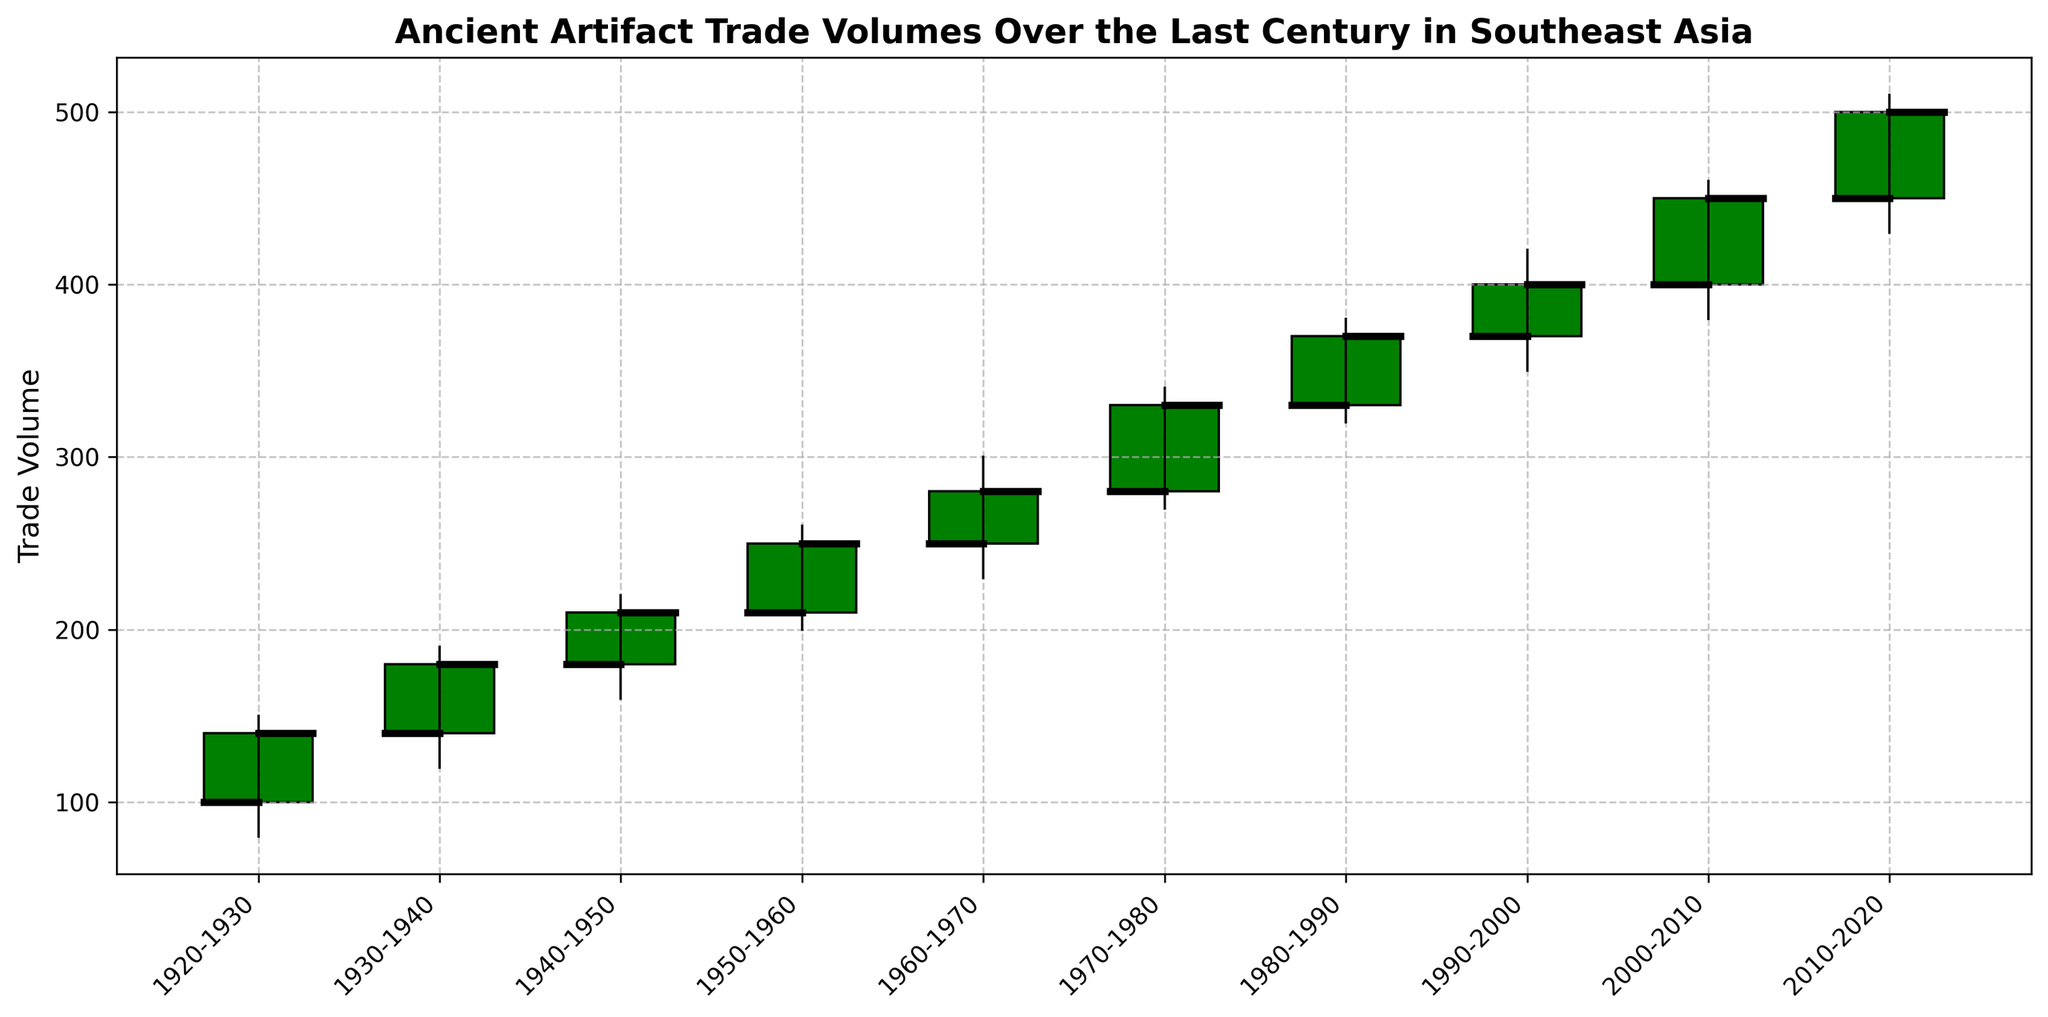What period shows the highest trade volume? The highest trade volume corresponds to the highest value in the "Close" column, which is 500 in the period 2010-2020.
Answer: 2010-2020 During which period does the trade volume see the most significant increase compared to the previous period? To determine this, we need to calculate the difference between consecutive "Close" values and identify the largest increase. From 1920-1930 to 1930-1940, the increase is 40 (180-140); from 1930-1940 to 1940-1950, it is 30 (210-180); and so on. The most significant increase is from 2000-2010 to 2010-2020, which is 50 (500-450).
Answer: 2000-2010 to 2010-2020 What is the smallest trade volume recorded in the figure, and during which period is it observed? The smallest trade volume corresponds to the lowest value in the "Low" column, which is 80 in the period 1920-1930.
Answer: 80, 1920-1930 Which period has the smallest difference between the high and low trade volumes? We need to subtract the "Low" value from the "High" value for each period to find the smallest difference: 
1920-1930: 70 
1930-1940: 70 
1940-1950: 60 
1950-1960: 60
1960-1970: 70 
1970-1980: 70
1980-1990: 60
1990-2000: 70
2000-2010: 80
2010-2020: 80
The smallest difference is 60, observed in periods 1940-1950, 1950-1960, and 1980-1990.
Answer: 60, 1940-1950, 1950-1960, 1980-1990 How many periods showed a decrease in trade volume by the end of the decade compared to the beginning? A decrease occurs when the "Close" value is less than the "Open" value. By examining each period, we see none of the periods show a decrease; all have "Close" values higher than "Open" values.
Answer: 0 During which decade does the trade volume first exceed 300? The "Close" value first exceeds 300 during the period 1970-1980, where the close value is 330.
Answer: 1970-1980 Identify the period with the highest volatility in trade volumes. Volatility can be gauged by the range between the "High" and "Low" values. The largest range would be calculated as: 
1920-1930: 70 
1930-1940: 70
1940-1950: 60
1950-1960: 60 
1960-1970: 70 
1970-1980: 70 
1980-1990: 60 
1990-2000: 70 
2000-2010: 80 
2010-2020: 80
The highest volatility is observed in periods 2000-2010 and 2010-2020, with ranges of 80.
Answer: 2000-2010, 2010-2020 